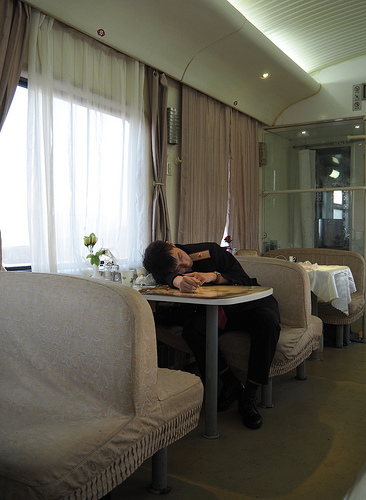<image>
Can you confirm if the man is on the seat? No. The man is not positioned on the seat. They may be near each other, but the man is not supported by or resting on top of the seat. 